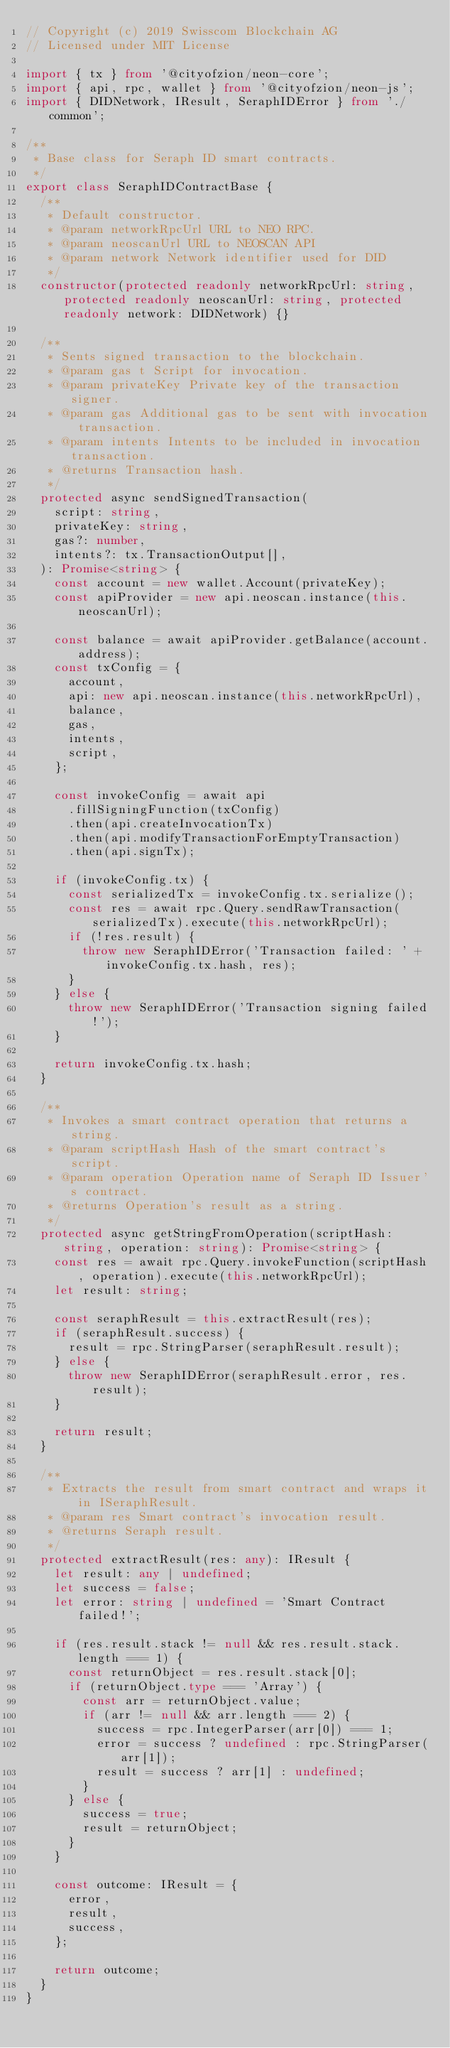<code> <loc_0><loc_0><loc_500><loc_500><_TypeScript_>// Copyright (c) 2019 Swisscom Blockchain AG
// Licensed under MIT License

import { tx } from '@cityofzion/neon-core';
import { api, rpc, wallet } from '@cityofzion/neon-js';
import { DIDNetwork, IResult, SeraphIDError } from './common';

/**
 * Base class for Seraph ID smart contracts.
 */
export class SeraphIDContractBase {
  /**
   * Default constructor.
   * @param networkRpcUrl URL to NEO RPC.
   * @param neoscanUrl URL to NEOSCAN API
   * @param network Network identifier used for DID
   */
  constructor(protected readonly networkRpcUrl: string, protected readonly neoscanUrl: string, protected readonly network: DIDNetwork) {}

  /**
   * Sents signed transaction to the blockchain.
   * @param gas t Script for invocation.
   * @param privateKey Private key of the transaction signer.
   * @param gas Additional gas to be sent with invocation transaction.
   * @param intents Intents to be included in invocation transaction.
   * @returns Transaction hash.
   */
  protected async sendSignedTransaction(
    script: string,
    privateKey: string,
    gas?: number,
    intents?: tx.TransactionOutput[],
  ): Promise<string> {
    const account = new wallet.Account(privateKey);
    const apiProvider = new api.neoscan.instance(this.neoscanUrl);

    const balance = await apiProvider.getBalance(account.address);
    const txConfig = {
      account,
      api: new api.neoscan.instance(this.networkRpcUrl),
      balance,
      gas,
      intents,
      script,
    };

    const invokeConfig = await api
      .fillSigningFunction(txConfig)
      .then(api.createInvocationTx)
      .then(api.modifyTransactionForEmptyTransaction)
      .then(api.signTx);

    if (invokeConfig.tx) {
      const serializedTx = invokeConfig.tx.serialize();
      const res = await rpc.Query.sendRawTransaction(serializedTx).execute(this.networkRpcUrl);
      if (!res.result) {
        throw new SeraphIDError('Transaction failed: ' + invokeConfig.tx.hash, res);
      }
    } else {
      throw new SeraphIDError('Transaction signing failed!');
    }

    return invokeConfig.tx.hash;
  }

  /**
   * Invokes a smart contract operation that returns a string.
   * @param scriptHash Hash of the smart contract's script.
   * @param operation Operation name of Seraph ID Issuer's contract.
   * @returns Operation's result as a string.
   */
  protected async getStringFromOperation(scriptHash: string, operation: string): Promise<string> {
    const res = await rpc.Query.invokeFunction(scriptHash, operation).execute(this.networkRpcUrl);
    let result: string;

    const seraphResult = this.extractResult(res);
    if (seraphResult.success) {
      result = rpc.StringParser(seraphResult.result);
    } else {
      throw new SeraphIDError(seraphResult.error, res.result);
    }

    return result;
  }

  /**
   * Extracts the result from smart contract and wraps it in ISeraphResult.
   * @param res Smart contract's invocation result.
   * @returns Seraph result.
   */
  protected extractResult(res: any): IResult {
    let result: any | undefined;
    let success = false;
    let error: string | undefined = 'Smart Contract failed!';

    if (res.result.stack != null && res.result.stack.length === 1) {
      const returnObject = res.result.stack[0];
      if (returnObject.type === 'Array') {
        const arr = returnObject.value;
        if (arr != null && arr.length === 2) {
          success = rpc.IntegerParser(arr[0]) === 1;
          error = success ? undefined : rpc.StringParser(arr[1]);
          result = success ? arr[1] : undefined;
        }
      } else {
        success = true;
        result = returnObject;
      }
    }

    const outcome: IResult = {
      error,
      result,
      success,
    };

    return outcome;
  }
}
</code> 